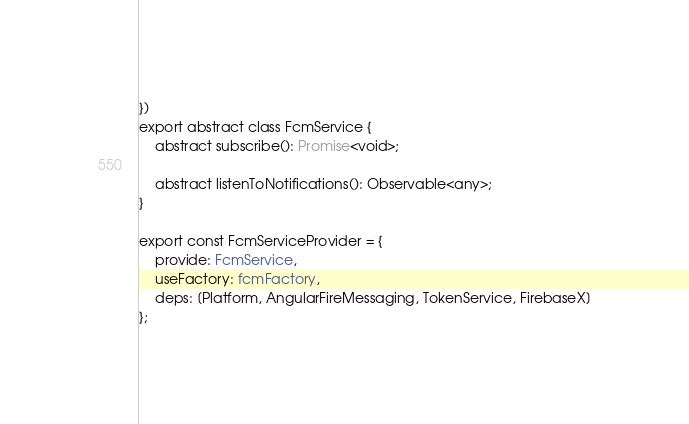<code> <loc_0><loc_0><loc_500><loc_500><_TypeScript_>})
export abstract class FcmService {
    abstract subscribe(): Promise<void>;

    abstract listenToNotifications(): Observable<any>;
}

export const FcmServiceProvider = {
    provide: FcmService,
    useFactory: fcmFactory,
    deps: [Platform, AngularFireMessaging, TokenService, FirebaseX]
};
</code> 